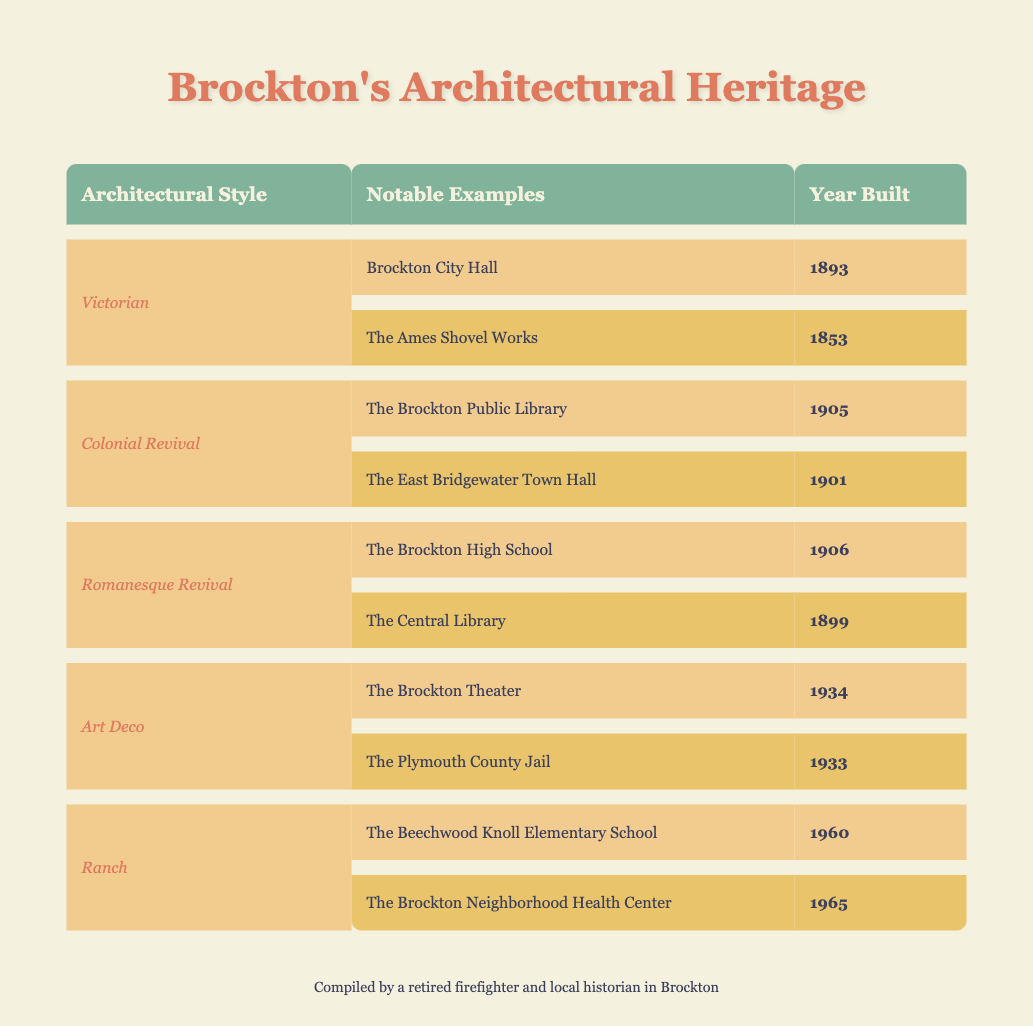What architectural style is the Brockton City Hall associated with? The table lists the architectural styles alongside notable examples. Since Brockton City Hall is listed under the "Victorian" style, we can conclude that it is associated with that style.
Answer: Victorian Which building was built in 1905? Looking at the table, "The Brockton Public Library" is listed with the year built as 1905. Therefore, it is the building that was constructed in that year.
Answer: The Brockton Public Library Are there any Art Deco buildings built before 1934? The table shows two Art Deco buildings: The Brockton Theater (built in 1934) and The Plymouth County Jail (built in 1933). The Plymouth County Jail was built before the Brockton Theater, so the answer is yes.
Answer: Yes What is the year difference between the oldest and newest buildings listed? From the table, the oldest building is "The Ames Shovel Works," built in 1853, while the newest is "The Brockton Neighborhood Health Center," built in 1965. The difference in years is calculated as 1965 - 1853 = 112 years.
Answer: 112 How many buildings were built in the 1900s? By examining the table, we identify that the buildings built in the 1900s are: The Brockton Public Library (1905), The East Bridgewater Town Hall (1901), The Brockton High School (1906), and The Central Library (1899). Thus, there are three buildings that were completed in the 1900s.
Answer: 3 Which style has the most examples listed, and how many are there? There are 5 different architectural styles listed in the table. The "Victorian" style has 2 examples (Brockton City Hall and The Ames Shovel Works), "Colonial Revival" has 2 (The Brockton Public Library and The East Bridgewater Town Hall), "Romanesque Revival" has 2 (The Brockton High School and The Central Library), "Art Deco" also has 2 (The Brockton Theater and The Plymouth County Jail), and "Ranch" has 2 (The Beechwood Knoll Elementary School and The Brockton Neighborhood Health Center). Therefore, no style has more than 2 examples.
Answer: No style has more Is the Central Library older than the Brockton High School? According to the years listed, The Central Library was built in 1899 and The Brockton High School was built in 1906. Since 1899 is earlier than 1906, The Central Library is indeed older.
Answer: Yes What is the average year built for Ranch-style buildings? The table shows two Ranch-style buildings: The Beechwood Knoll Elementary School (1960) and The Brockton Neighborhood Health Center (1965). To find the average, we add the years: 1960 + 1965 = 3925. Then we divide by the number of buildings: 3925 / 2 = 1962.5. Thus, the average year built for Ranch-style buildings is 1962.5.
Answer: 1962.5 